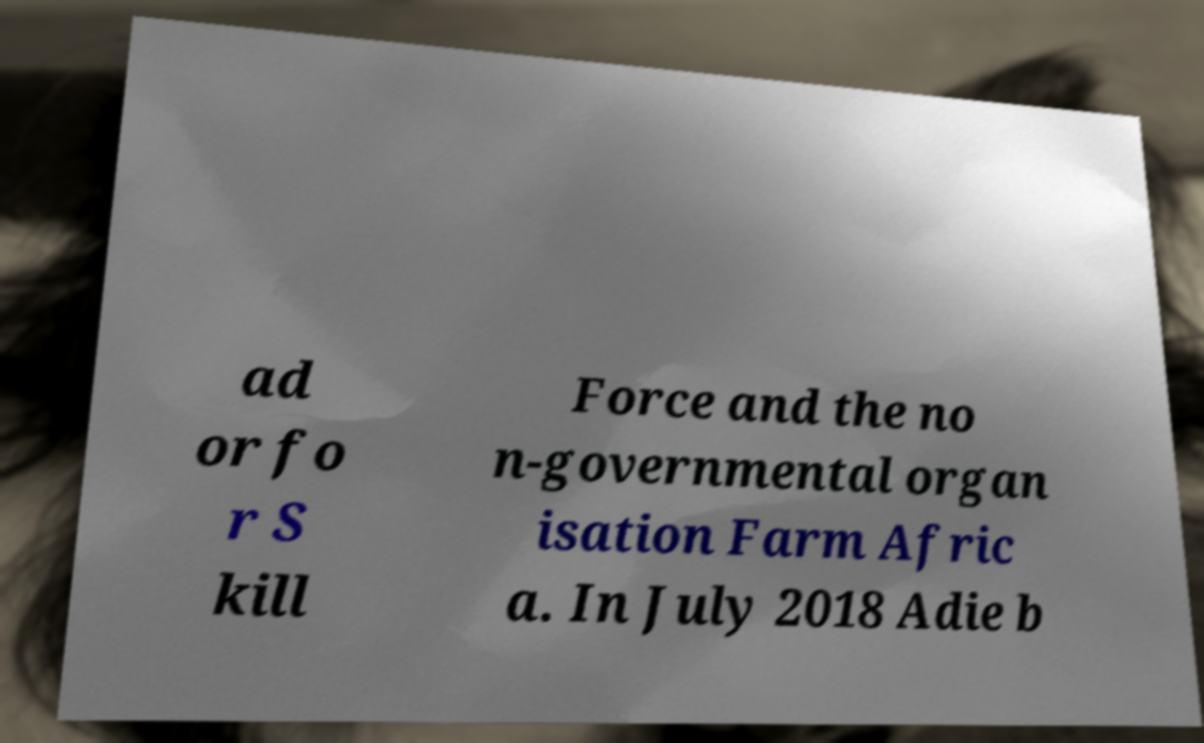There's text embedded in this image that I need extracted. Can you transcribe it verbatim? ad or fo r S kill Force and the no n-governmental organ isation Farm Afric a. In July 2018 Adie b 